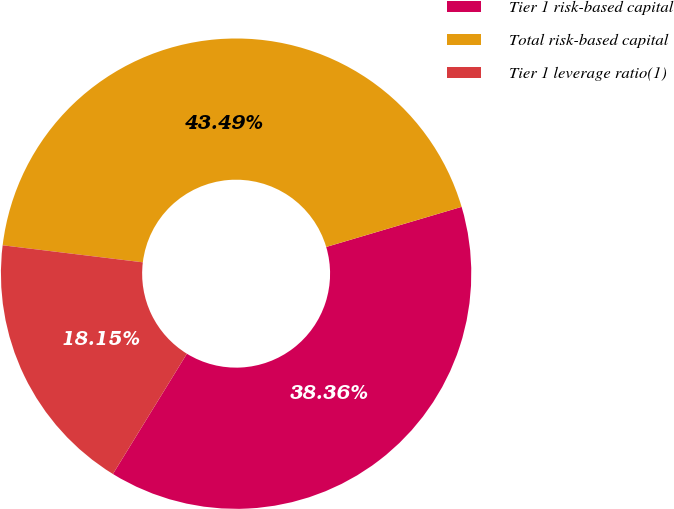<chart> <loc_0><loc_0><loc_500><loc_500><pie_chart><fcel>Tier 1 risk-based capital<fcel>Total risk-based capital<fcel>Tier 1 leverage ratio(1)<nl><fcel>38.36%<fcel>43.49%<fcel>18.15%<nl></chart> 